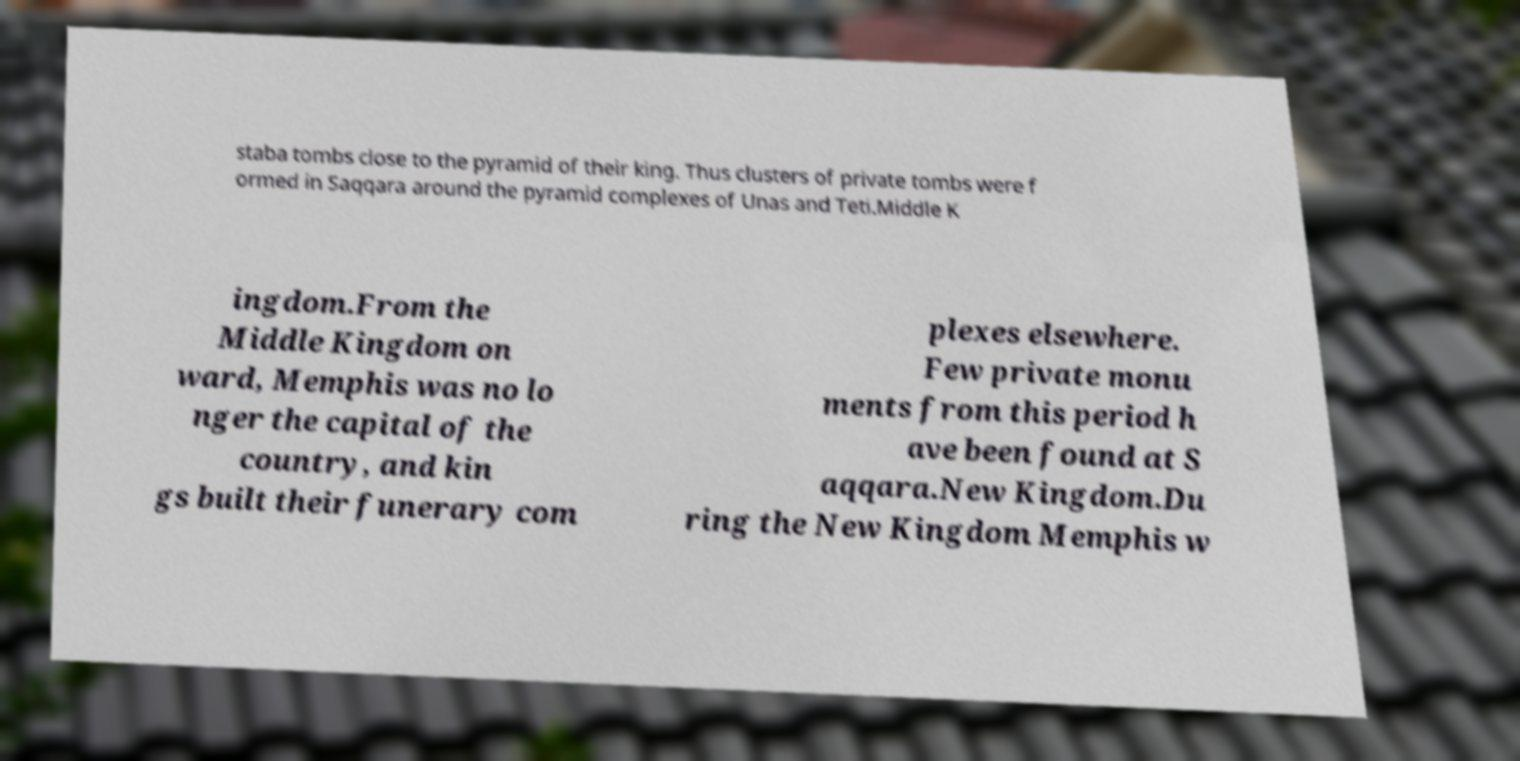Please identify and transcribe the text found in this image. staba tombs close to the pyramid of their king. Thus clusters of private tombs were f ormed in Saqqara around the pyramid complexes of Unas and Teti.Middle K ingdom.From the Middle Kingdom on ward, Memphis was no lo nger the capital of the country, and kin gs built their funerary com plexes elsewhere. Few private monu ments from this period h ave been found at S aqqara.New Kingdom.Du ring the New Kingdom Memphis w 